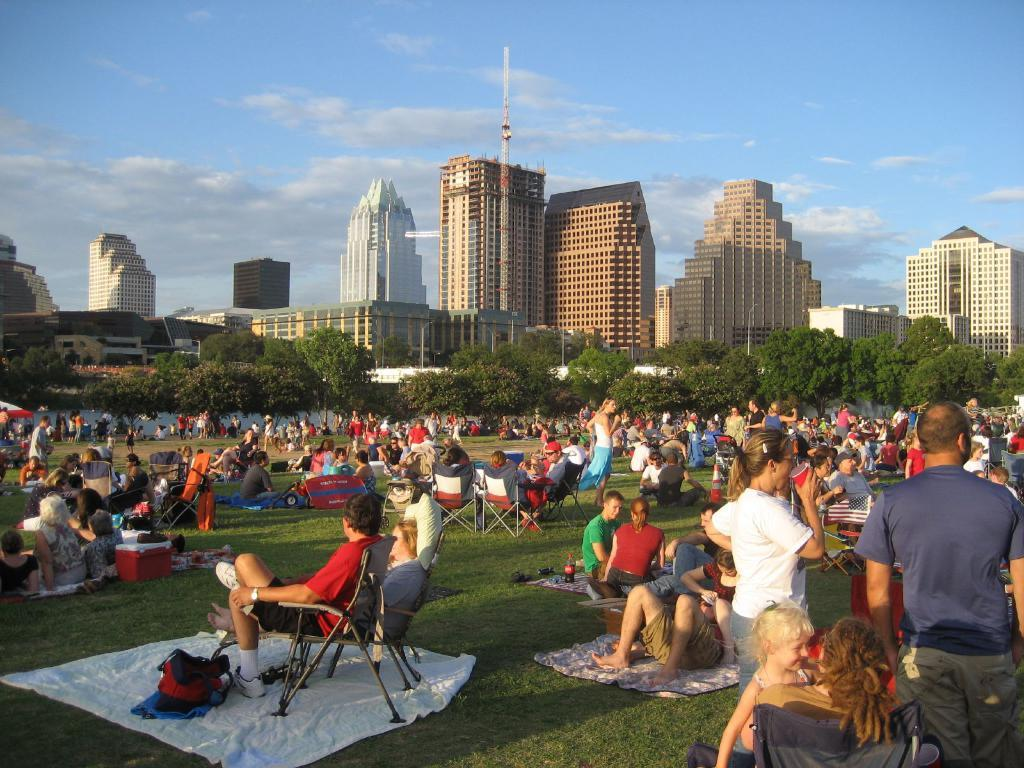How many people are in the image? There are people in the image, but the exact number is not specified. What are some of the people doing in the image? Some people are sitting on chairs in the image. What can be seen on the grass in the image? There are objects on the grass in the image. What is visible in the background of the image? There are trees, buildings, and the sky visible in the background of the image. What is the condition of the sky in the image? The sky is visible in the background of the image, and there are clouds present. Can you tell me what type of example the goat is setting in the image? There is no goat present in the image, so it is not possible to determine what type of example it might be setting. 